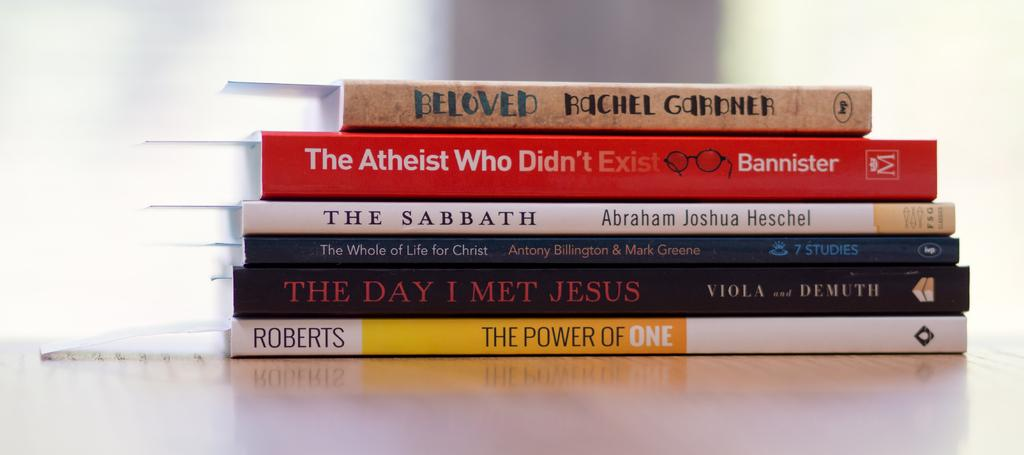Provide a one-sentence caption for the provided image. stacked up books on a table include Beloved and The Sabbath. 